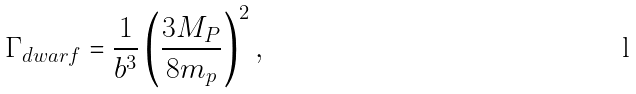Convert formula to latex. <formula><loc_0><loc_0><loc_500><loc_500>\Gamma _ { d w a r f } = \frac { 1 } { b ^ { 3 } } \left ( \frac { 3 M _ { P } } { 8 m _ { p } } \right ) ^ { 2 } ,</formula> 